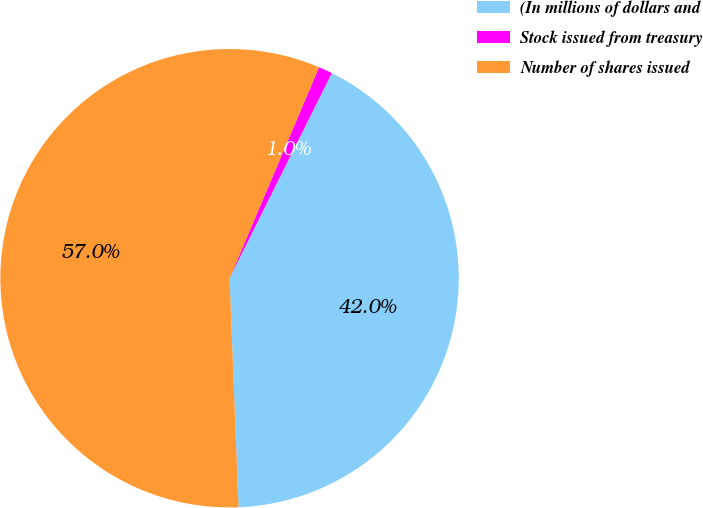Convert chart. <chart><loc_0><loc_0><loc_500><loc_500><pie_chart><fcel>(In millions of dollars and<fcel>Stock issued from treasury<fcel>Number of shares issued<nl><fcel>42.01%<fcel>0.98%<fcel>57.0%<nl></chart> 